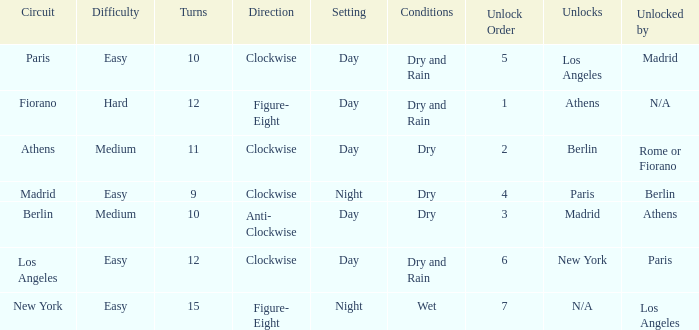What is the difficulty of the athens circuit? Medium. 